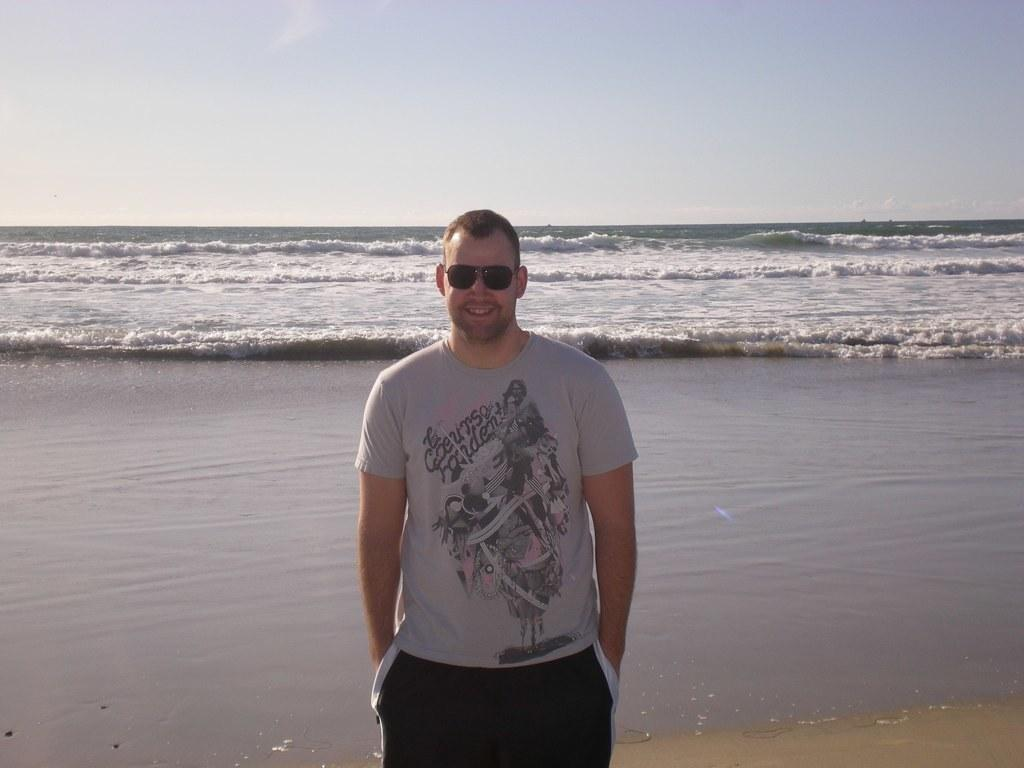What is the main subject of the image? There is a person in the image. What is the person doing in the image? The person is standing and smiling. What is the person wearing in the image? The person is wearing goggles. What can be seen in the background of the image? There are water waves and the sky visible in the background of the image. What type of cloth is being used to cover the person's thumb in the image? There is no cloth present in the image, nor is there any indication that the person's thumb is covered. 